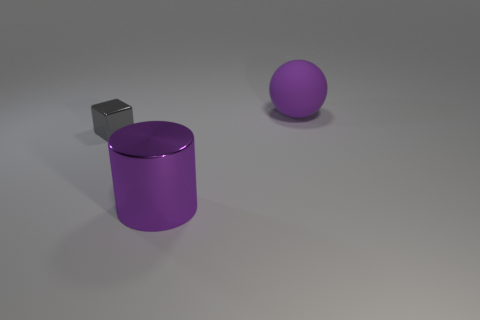Is there anything else that is the same size as the gray metallic cube?
Keep it short and to the point. No. The other large object that is the same color as the big metal object is what shape?
Your response must be concise. Sphere. Is there anything else that is made of the same material as the purple sphere?
Make the answer very short. No. What number of small objects are either yellow metallic objects or gray metal cubes?
Provide a short and direct response. 1. There is a big purple object behind the gray shiny block; is its shape the same as the large purple metallic object?
Your response must be concise. No. Is the number of big purple metallic cylinders less than the number of rubber blocks?
Make the answer very short. No. Are there any other things that are the same color as the small block?
Ensure brevity in your answer.  No. There is a large object in front of the matte thing; what is its shape?
Your answer should be very brief. Cylinder. Does the ball have the same color as the metal object to the left of the big cylinder?
Keep it short and to the point. No. Are there an equal number of small cubes in front of the small gray metallic object and things on the left side of the purple matte ball?
Ensure brevity in your answer.  No. 